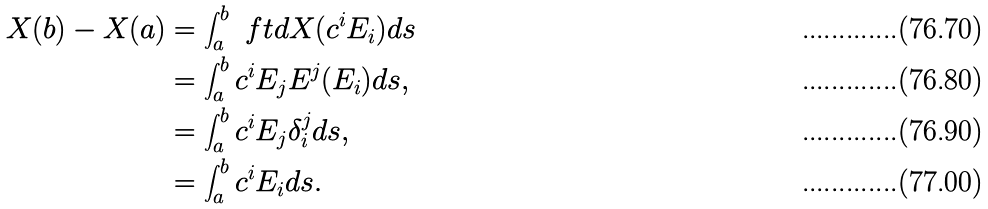Convert formula to latex. <formula><loc_0><loc_0><loc_500><loc_500>X ( b ) - X ( a ) & = \int _ { a } ^ { b } \ f t { d } X ( c ^ { i } E _ { i } ) d s \\ & = \int _ { a } ^ { b } c ^ { i } E _ { j } E ^ { j } ( E _ { i } ) d s , \\ & = \int _ { a } ^ { b } c ^ { i } E _ { j } \delta ^ { j } _ { i } d s , \\ & = \int _ { a } ^ { b } c ^ { i } E _ { i } d s .</formula> 